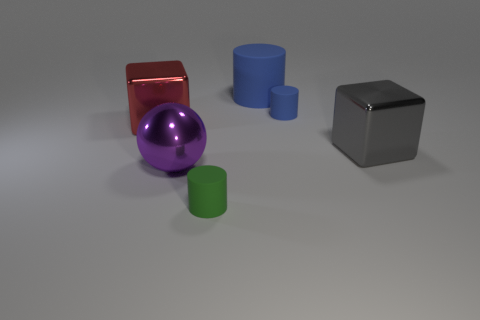Subtract all big matte cylinders. How many cylinders are left? 2 Add 1 small purple blocks. How many objects exist? 7 Subtract 0 brown cylinders. How many objects are left? 6 Subtract all spheres. How many objects are left? 5 Subtract 1 blocks. How many blocks are left? 1 Subtract all blue balls. Subtract all cyan blocks. How many balls are left? 1 Subtract all purple cubes. How many brown cylinders are left? 0 Subtract all tiny blue cylinders. Subtract all large yellow cubes. How many objects are left? 5 Add 3 green rubber things. How many green rubber things are left? 4 Add 1 gray shiny cubes. How many gray shiny cubes exist? 2 